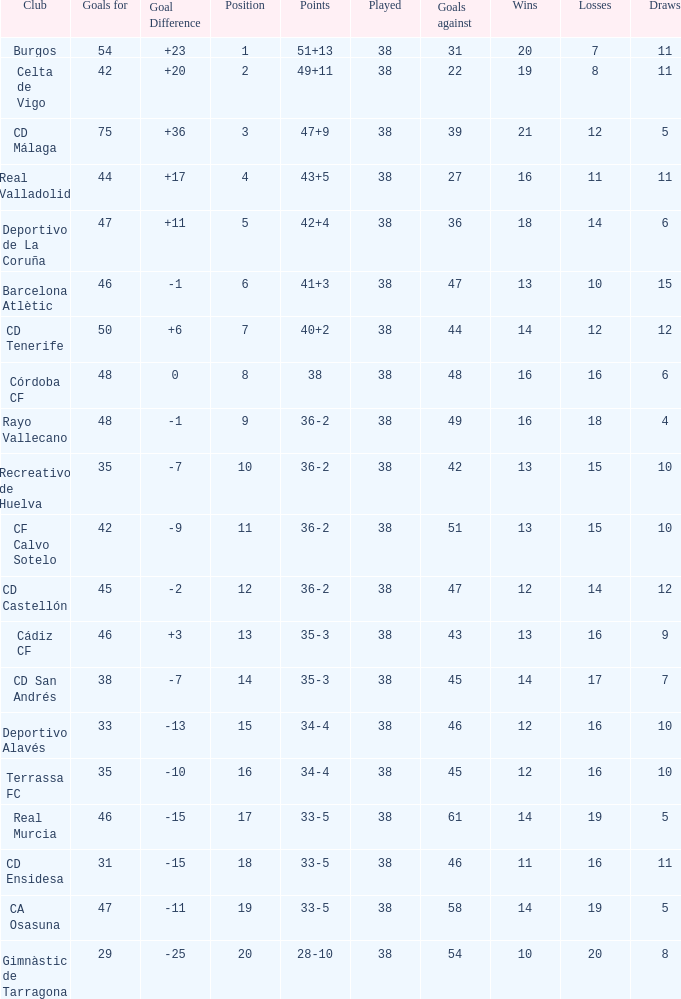Which is the lowest played with 28-10 points and goals higher than 29? None. 